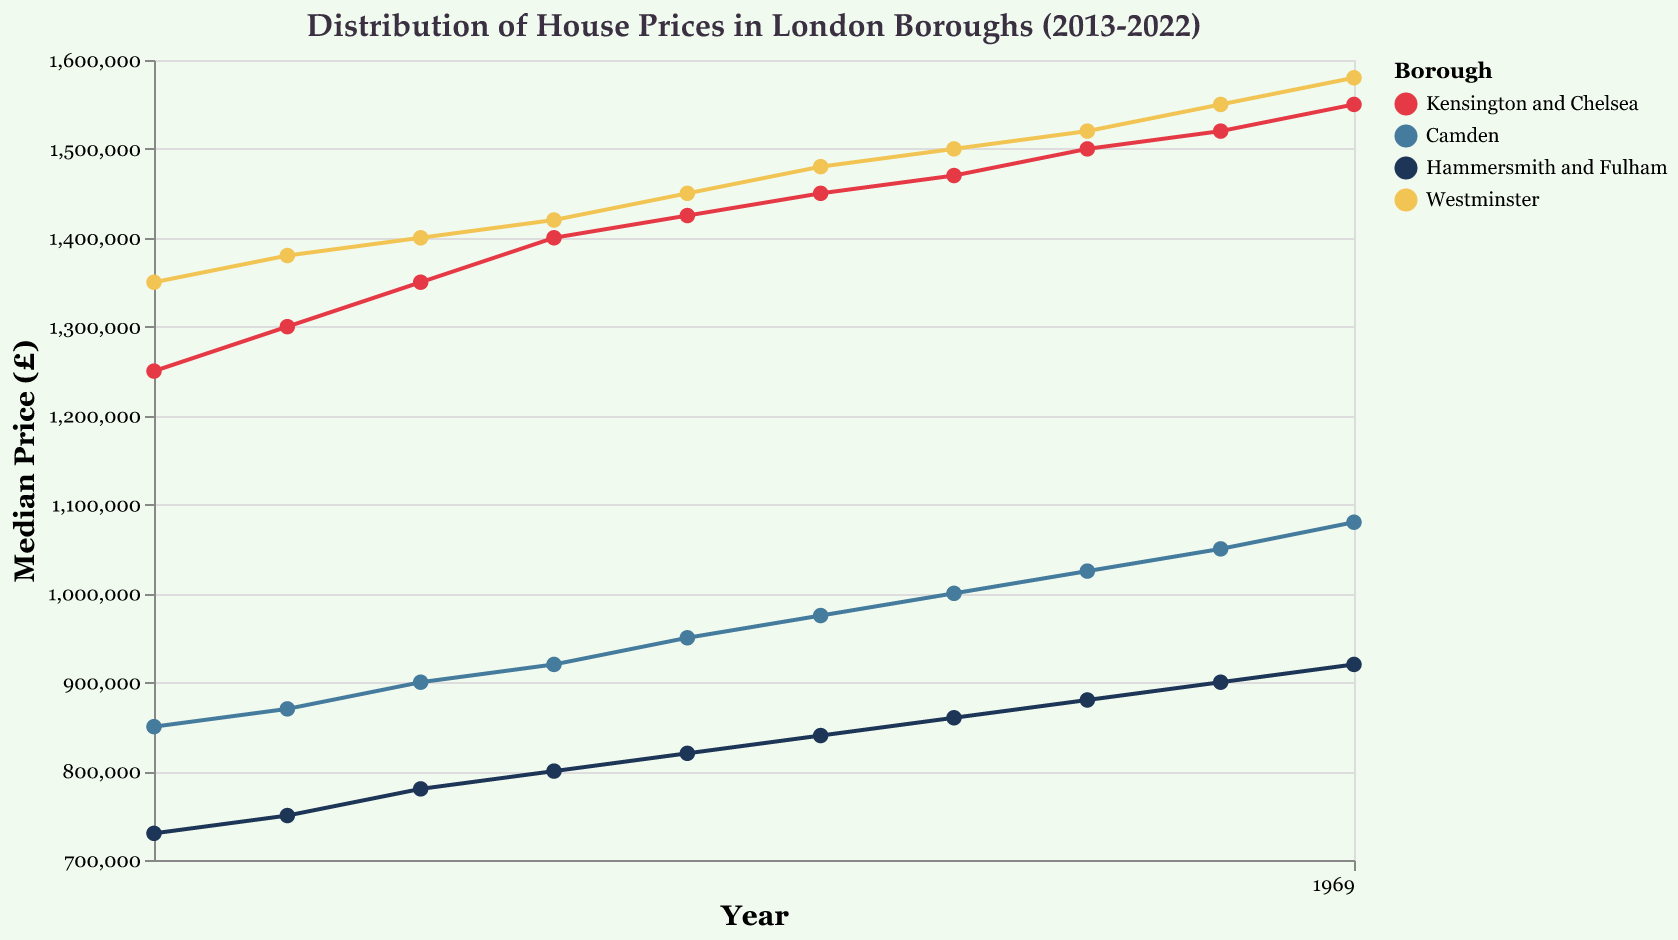How many boroughs are displayed in the figure's legend? The figure's legend shows four distinct colors representing four boroughs: Kensington and Chelsea, Camden, Hammersmith and Fulham, and Westminster.
Answer: 4 Which borough had the highest median house price in 2022? The line chart indicates that the borough Westminster reached the highest median house price in 2022 when comparing the values between the boroughs.
Answer: Westminster What is the overall trend in Kensington and Chelsea's median house prices from 2013 to 2022? By observing the line corresponding to Kensington and Chelsea, we note a steady increase from £1,250,000 in 2013 to £1,550,000 in 2022.
Answer: Increasing What was the median house price difference between Camden and Hammersmith and Fulham in 2022? In 2022, Camden's median price was £1,080,000 and Hammersmith and Fulham's was £920,000. The difference is calculated as £1,080,000 - £920,000.
Answer: £160,000 Which year saw the largest increase in median house price for Westminster? By inspecting Westminster’s line, the largest increase happened between 2021 (£1,550,000) and 2022 (£1,580,000), resulting in a £30,000 increase.
Answer: 2022 Compare the median house prices of Camden and Westminster in 2015. Which was higher? The median house price for Camden in 2015 was £900,000, while for Westminster it was £1,400,000. Therefore, Westminster had the higher price.
Answer: Westminster Did any borough experience a decrease in median house price from one year to the next? Examining the lines, none of the boroughs show a decrease in house prices from one year to the next; all values either increase or remain the same each year.
Answer: No Calculate the average median house price for Hammersmith and Fulham across the decade. Summing up each median price for the years 2013-2022 is (730,000 + 750,000 + 780,000 + 800,000 + 820,000 + 840,000 + 860,000 + 880,000 + 900,000 + 920,000) = £8,280,000. Dividing by 10, the average is £828,000.
Answer: £828,000 Which borough had the least volatile (most stable) median house price trend over the years? By looking at the smoothness and steadiness of each line, Hammersmith and Fulham shows the least fluctuation, implying the most stable trend.
Answer: Hammersmith and Fulham 